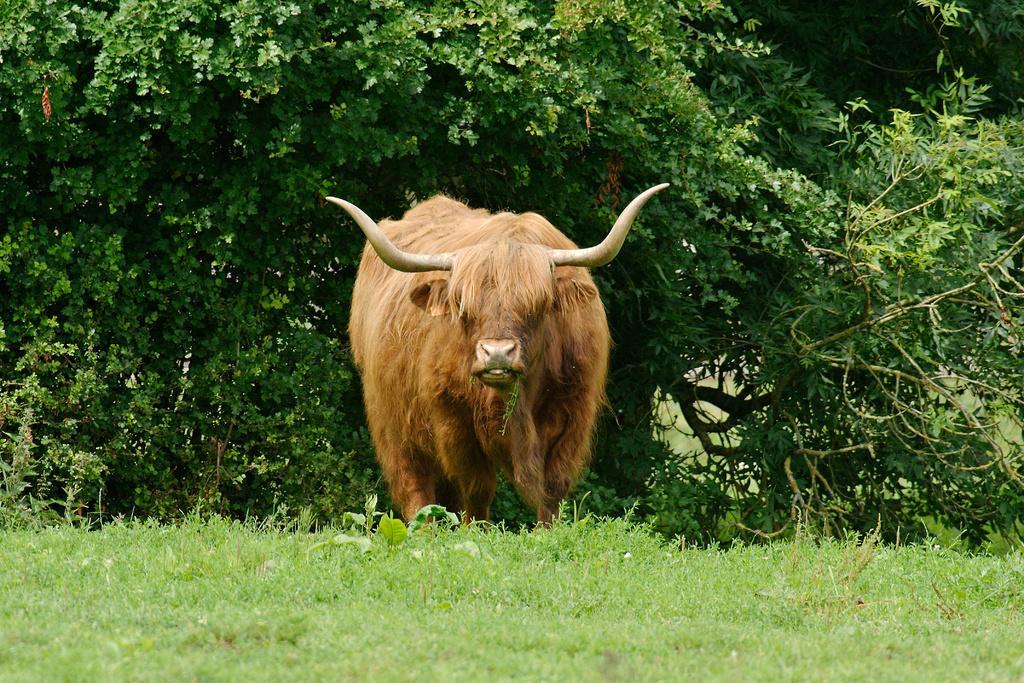In one or two sentences, can you explain what this image depicts? In the center of the image we can see one yak, which is in brown color. At the bottom of the image, we can see the grass. In the background we can see trees. 